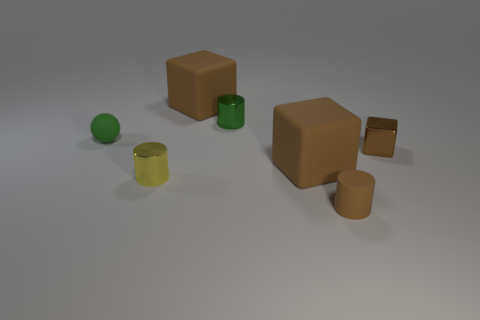There is a green thing left of the green metallic cylinder; is its size the same as the small green cylinder?
Your answer should be compact. Yes. Is the number of small green rubber balls that are on the right side of the small yellow shiny thing less than the number of tiny rubber cylinders that are behind the tiny green rubber thing?
Provide a succinct answer. No. Is the color of the small sphere the same as the small block?
Ensure brevity in your answer.  No. Are there fewer green rubber spheres that are behind the small green rubber sphere than yellow metal cylinders?
Give a very brief answer. Yes. What material is the cylinder that is the same color as the tiny cube?
Provide a short and direct response. Rubber. Are the tiny yellow cylinder and the small green ball made of the same material?
Give a very brief answer. No. What number of cubes have the same material as the small yellow cylinder?
Give a very brief answer. 1. There is a cylinder that is the same material as the small sphere; what is its color?
Your response must be concise. Brown. The small green metallic thing is what shape?
Keep it short and to the point. Cylinder. What is the big object that is behind the small brown shiny thing made of?
Keep it short and to the point. Rubber. 